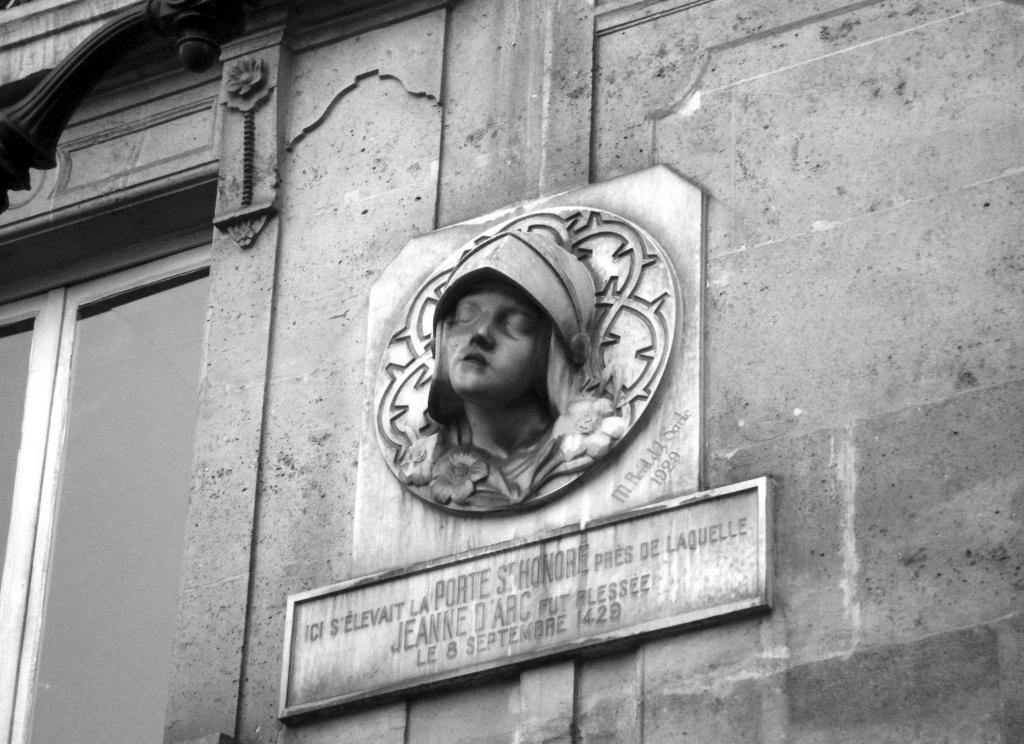How would you summarize this image in a sentence or two? In this image there is a sculpture of a person is on the wall having a window. A name board is attached to the wall. 